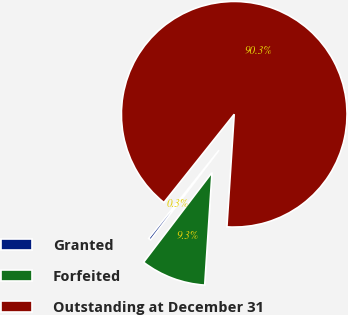<chart> <loc_0><loc_0><loc_500><loc_500><pie_chart><fcel>Granted<fcel>Forfeited<fcel>Outstanding at December 31<nl><fcel>0.34%<fcel>9.34%<fcel>90.33%<nl></chart> 